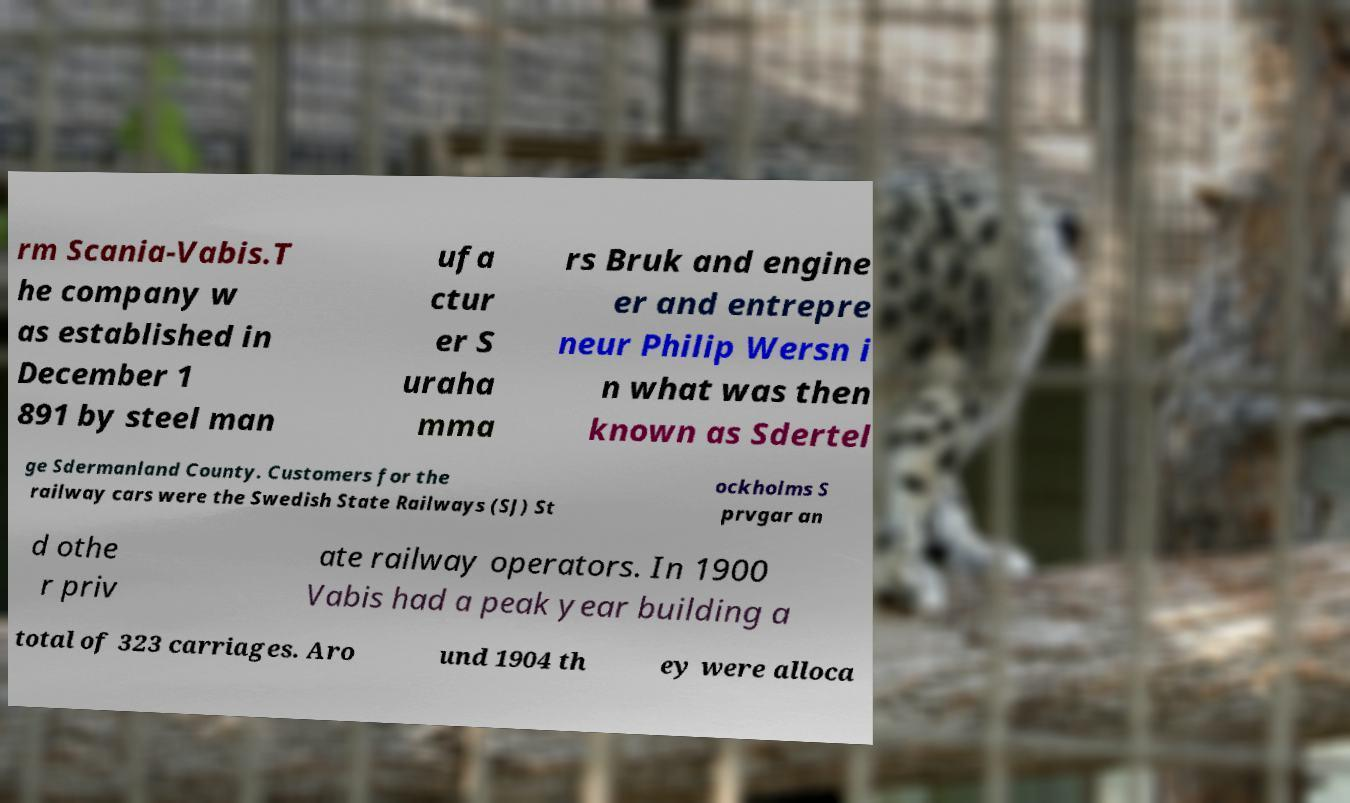Could you assist in decoding the text presented in this image and type it out clearly? rm Scania-Vabis.T he company w as established in December 1 891 by steel man ufa ctur er S uraha mma rs Bruk and engine er and entrepre neur Philip Wersn i n what was then known as Sdertel ge Sdermanland County. Customers for the railway cars were the Swedish State Railways (SJ) St ockholms S prvgar an d othe r priv ate railway operators. In 1900 Vabis had a peak year building a total of 323 carriages. Aro und 1904 th ey were alloca 